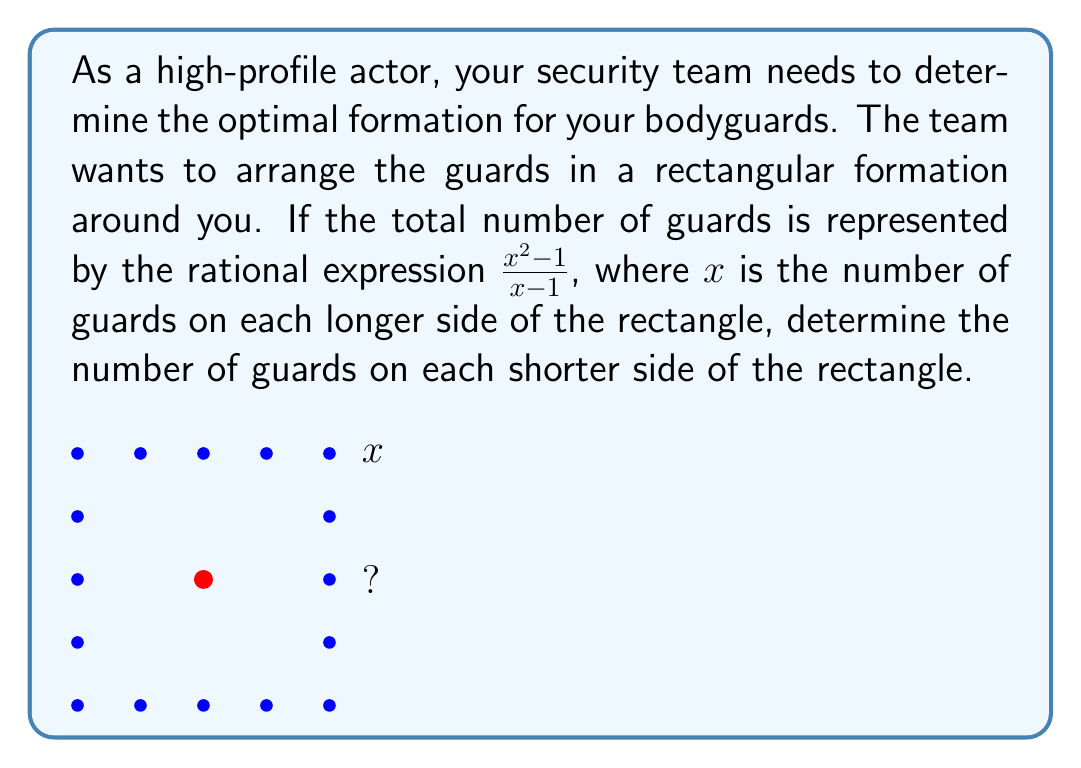Show me your answer to this math problem. Let's approach this step-by-step:

1) We're given that the total number of guards is $\frac{x^2-1}{x-1}$, where $x$ is the number of guards on each longer side.

2) Let's call the number of guards on each shorter side $y$. We don't know this value yet.

3) In a rectangular formation, the total number of guards would be:
   $2x + 2y - 4$
   (We subtract 4 to avoid counting the corner guards twice)

4) We can set up an equation:
   $$\frac{x^2-1}{x-1} = 2x + 2y - 4$$

5) Let's simplify the left side of the equation:
   $\frac{x^2-1}{x-1} = x + 1$ (for $x \neq 1$)

6) Now our equation is:
   $$x + 1 = 2x + 2y - 4$$

7) Subtract $x$ from both sides:
   $$1 = x + 2y - 4$$

8) Add 4 to both sides:
   $$5 = x + 2y$$

9) Subtract $x$ from both sides:
   $$5 - x = 2y$$

10) Divide both sides by 2:
    $$\frac{5-x}{2} = y$$

Therefore, the number of guards on each shorter side is $\frac{5-x}{2}$.
Answer: $\frac{5-x}{2}$ 